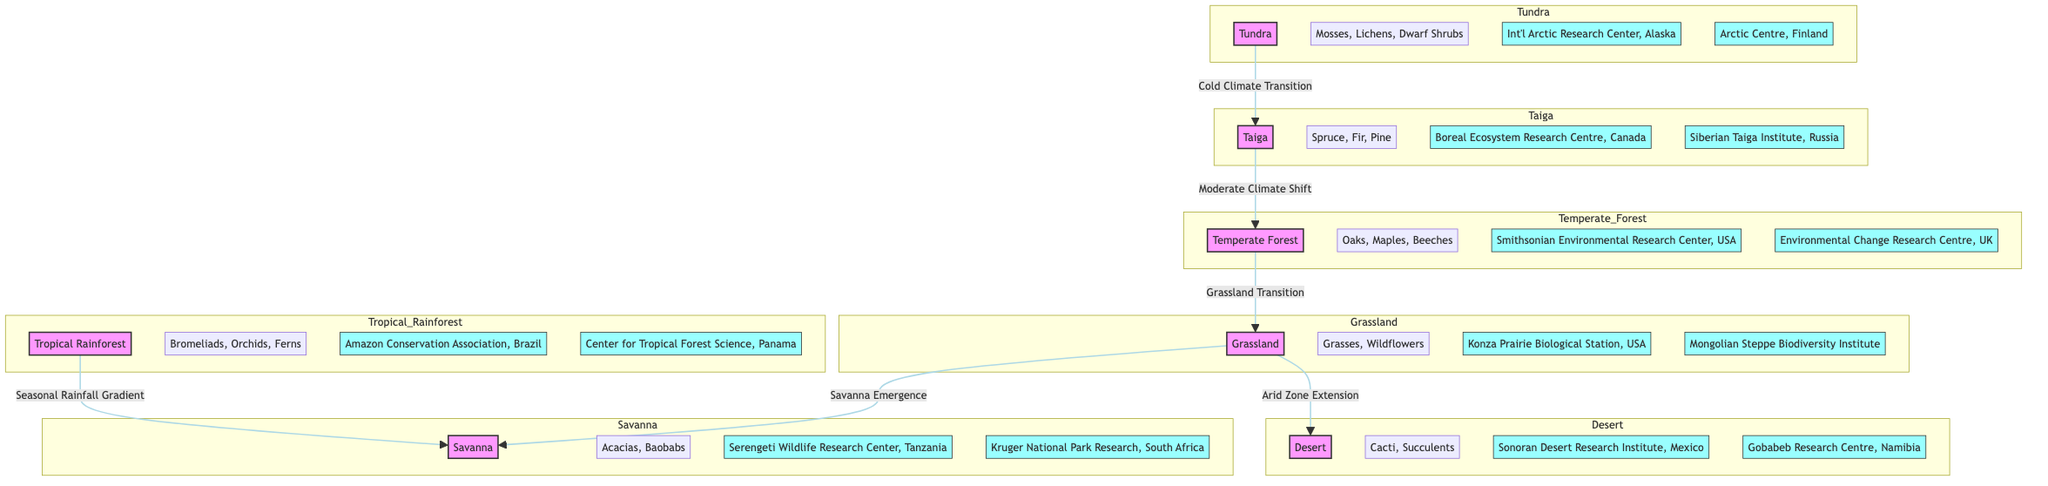What are the characteristic flora of the Tundra biome? The diagram indicates that the characteristic flora of the Tundra biome includes Mosses, Lichens, and Dwarf Shrubs, as shown in the corresponding section of the diagram.
Answer: Mosses, Lichens, Dwarf Shrubs How many international research centers are associated with the Grassland biome? By counting the research centers listed under the Grassland biome in the diagram, we find two: Konza Prairie Biological Station and Mongolian Steppe Biodiversity Institute.
Answer: 2 Which biome has the research center named "Gobabeb Research Centre"? According to the diagram, the Gobabeb Research Centre is associated with the Desert biome, as indicated in the appropriate section of the diagram.
Answer: Desert What climate condition transitions from Tundra to Taiga? The diagram specifies that the transition from Tundra to Taiga is characterized by a "Cold Climate Transition," which describes the change between these biomes.
Answer: Cold Climate Transition Which biome is positioned in between Temperate Forest and Grassland? The relationship in the diagram shows that Grassland is positioned after Temperate Forest, making Grassland the biome that follows Temperate Forest directly.
Answer: Grassland How many key international research sites are located in the Tropical Rainforest biome? The diagram identifies two research sites associated with the Tropical Rainforest: Amazon Conservation Association and Center for Tropical Forest Science.
Answer: 2 Which flora type is characteristic of the Savanna biome? The diagram lists Acacias and Baobabs as the characteristic flora types for the Savanna biome, providing a direct association with this specific ecosystem.
Answer: Acacias, Baobabs What research center is located in Finland? Referring to the diagram, the Arctic Centre in Finland is highlighted as an international research center focused on the related ecosystem of the Tundra biome.
Answer: Arctic Centre, Finland What is the ecological transition from Grassland to Desert? The diagram outlines the transition between Grassland and Desert as "Arid Zone Extension," describing the change from a more vegetative ecosystem to arid landscapes.
Answer: Arid Zone Extension 